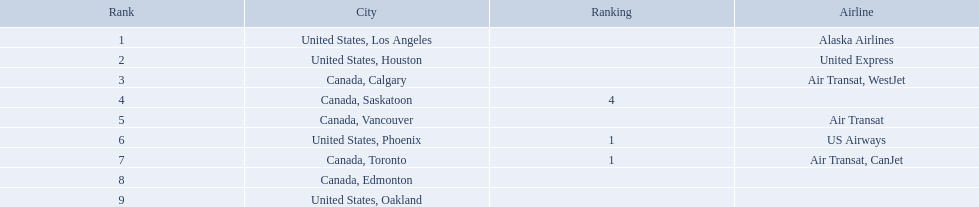Which cities had less than 2,000 passengers? United States, Phoenix, Canada, Toronto, Canada, Edmonton, United States, Oakland. Of these cities, which had fewer than 1,000 passengers? Canada, Edmonton, United States, Oakland. Of the cities in the previous answer, which one had only 107 passengers? United States, Oakland. What numbers are in the passengers column? 14,749, 5,465, 3,761, 2,282, 2,103, 1,829, 1,202, 110, 107. Which number is the lowest number in the passengers column? 107. What city is associated with this number? United States, Oakland. Where are the destinations of the airport? United States, Los Angeles, United States, Houston, Canada, Calgary, Canada, Saskatoon, Canada, Vancouver, United States, Phoenix, Canada, Toronto, Canada, Edmonton, United States, Oakland. What is the number of passengers to phoenix? 1,829. 